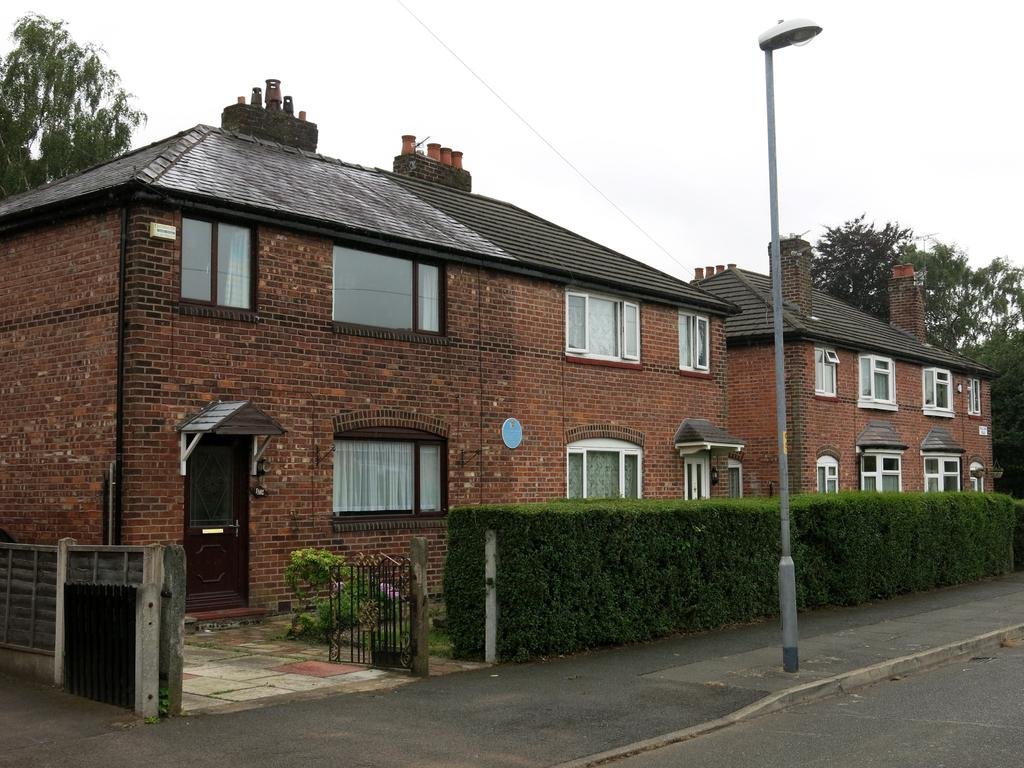What type of structure is visible in the image? There is a building in the image. What feature of the building is mentioned in the facts? The building has windows. What architectural elements can be seen in the image? There is a gate, a fence, and a door in the image. What natural elements are present in the image? There is a plant and a tree in the image. What additional feature is mentioned in the facts? There is a skylight pole in the image. What man-made elements are present in the image? There is a footpath and a road in the image. Can you tell me the direction the stranger is walking in the image? There is no stranger present in the image, so it is not possible to determine the direction they might be walking. 